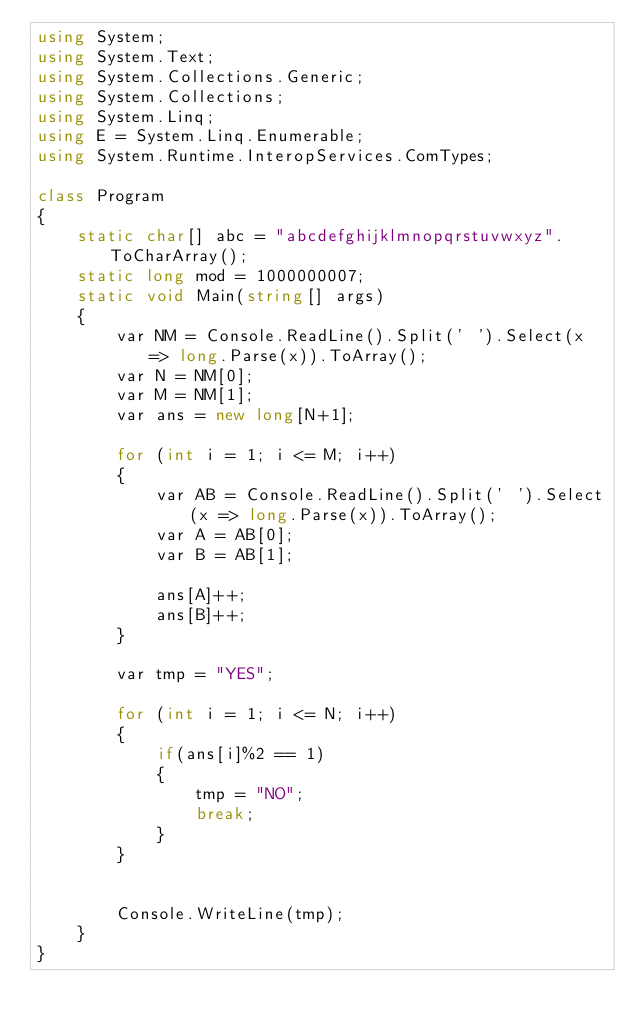<code> <loc_0><loc_0><loc_500><loc_500><_C#_>using System;
using System.Text;
using System.Collections.Generic;
using System.Collections;
using System.Linq;
using E = System.Linq.Enumerable;
using System.Runtime.InteropServices.ComTypes;

class Program
{
    static char[] abc = "abcdefghijklmnopqrstuvwxyz".ToCharArray();
    static long mod = 1000000007;
    static void Main(string[] args)
    {
        var NM = Console.ReadLine().Split(' ').Select(x => long.Parse(x)).ToArray();
        var N = NM[0];
        var M = NM[1];
        var ans = new long[N+1];

        for (int i = 1; i <= M; i++)
        {
            var AB = Console.ReadLine().Split(' ').Select(x => long.Parse(x)).ToArray();
            var A = AB[0];
            var B = AB[1];

            ans[A]++;
            ans[B]++;
        }

        var tmp = "YES";

        for (int i = 1; i <= N; i++)
        {
            if(ans[i]%2 == 1)
            {
                tmp = "NO";
                break;
            }
        }
        

        Console.WriteLine(tmp);
    }
}
</code> 